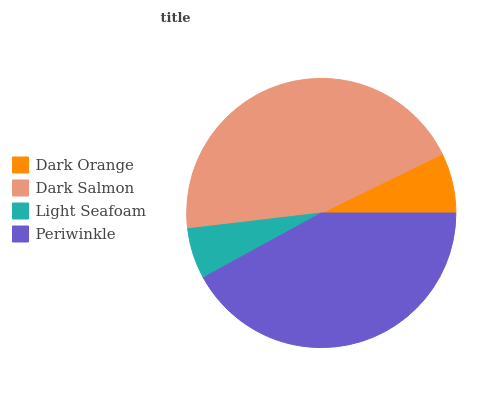Is Light Seafoam the minimum?
Answer yes or no. Yes. Is Dark Salmon the maximum?
Answer yes or no. Yes. Is Dark Salmon the minimum?
Answer yes or no. No. Is Light Seafoam the maximum?
Answer yes or no. No. Is Dark Salmon greater than Light Seafoam?
Answer yes or no. Yes. Is Light Seafoam less than Dark Salmon?
Answer yes or no. Yes. Is Light Seafoam greater than Dark Salmon?
Answer yes or no. No. Is Dark Salmon less than Light Seafoam?
Answer yes or no. No. Is Periwinkle the high median?
Answer yes or no. Yes. Is Dark Orange the low median?
Answer yes or no. Yes. Is Dark Orange the high median?
Answer yes or no. No. Is Periwinkle the low median?
Answer yes or no. No. 